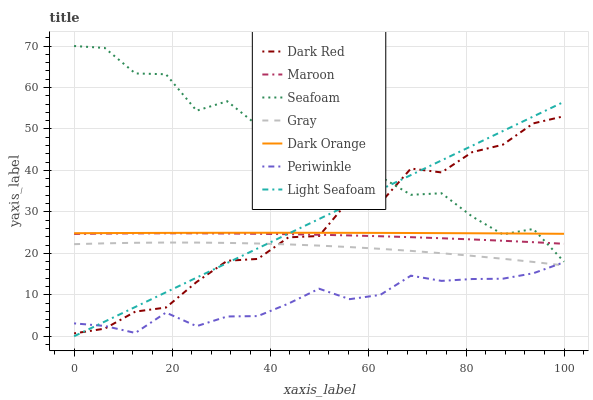Does Periwinkle have the minimum area under the curve?
Answer yes or no. Yes. Does Seafoam have the maximum area under the curve?
Answer yes or no. Yes. Does Gray have the minimum area under the curve?
Answer yes or no. No. Does Gray have the maximum area under the curve?
Answer yes or no. No. Is Light Seafoam the smoothest?
Answer yes or no. Yes. Is Dark Red the roughest?
Answer yes or no. Yes. Is Gray the smoothest?
Answer yes or no. No. Is Gray the roughest?
Answer yes or no. No. Does Gray have the lowest value?
Answer yes or no. No. Does Seafoam have the highest value?
Answer yes or no. Yes. Does Gray have the highest value?
Answer yes or no. No. Is Periwinkle less than Maroon?
Answer yes or no. Yes. Is Seafoam greater than Gray?
Answer yes or no. Yes. Does Periwinkle intersect Gray?
Answer yes or no. Yes. Is Periwinkle less than Gray?
Answer yes or no. No. Is Periwinkle greater than Gray?
Answer yes or no. No. Does Periwinkle intersect Maroon?
Answer yes or no. No. 